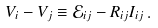<formula> <loc_0><loc_0><loc_500><loc_500>V _ { i } - V _ { j } \equiv \mathcal { E } _ { i j } - R _ { i j } I _ { i j } \, .</formula> 